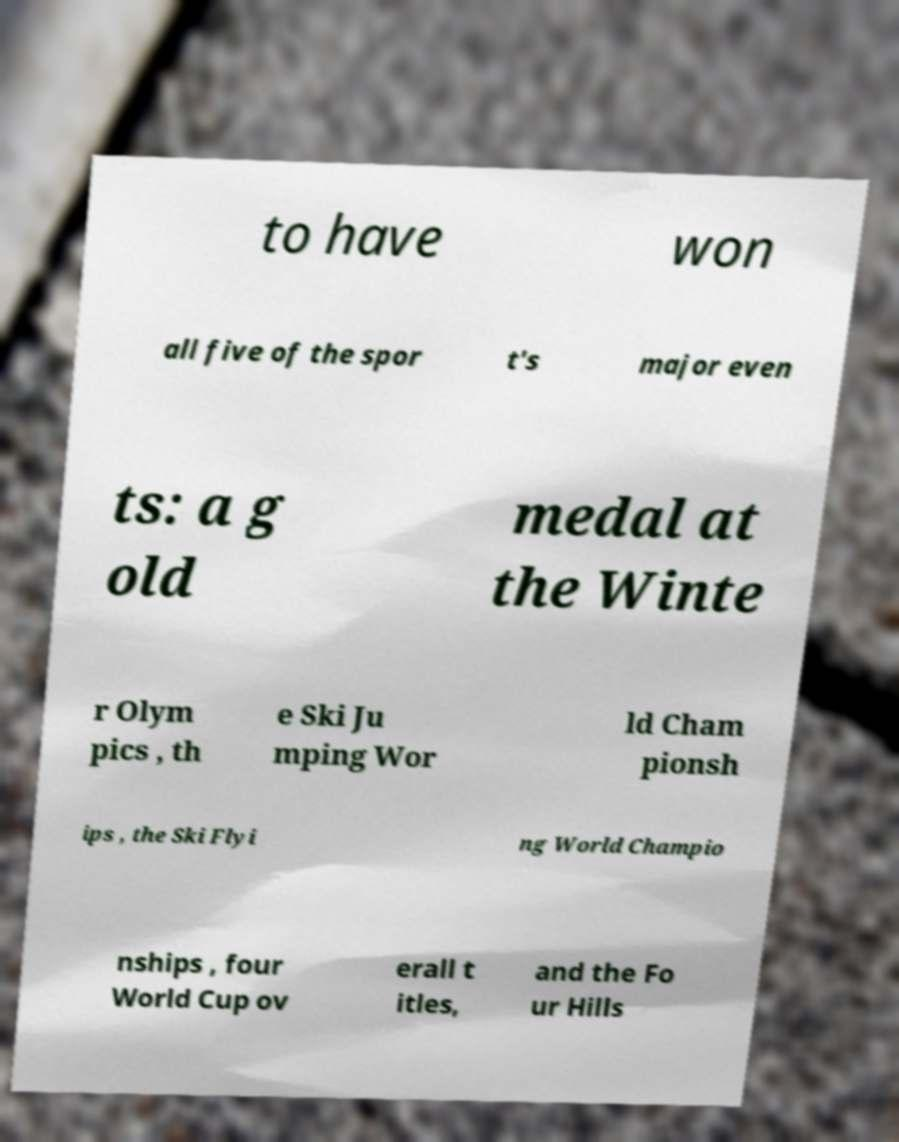What messages or text are displayed in this image? I need them in a readable, typed format. to have won all five of the spor t's major even ts: a g old medal at the Winte r Olym pics , th e Ski Ju mping Wor ld Cham pionsh ips , the Ski Flyi ng World Champio nships , four World Cup ov erall t itles, and the Fo ur Hills 